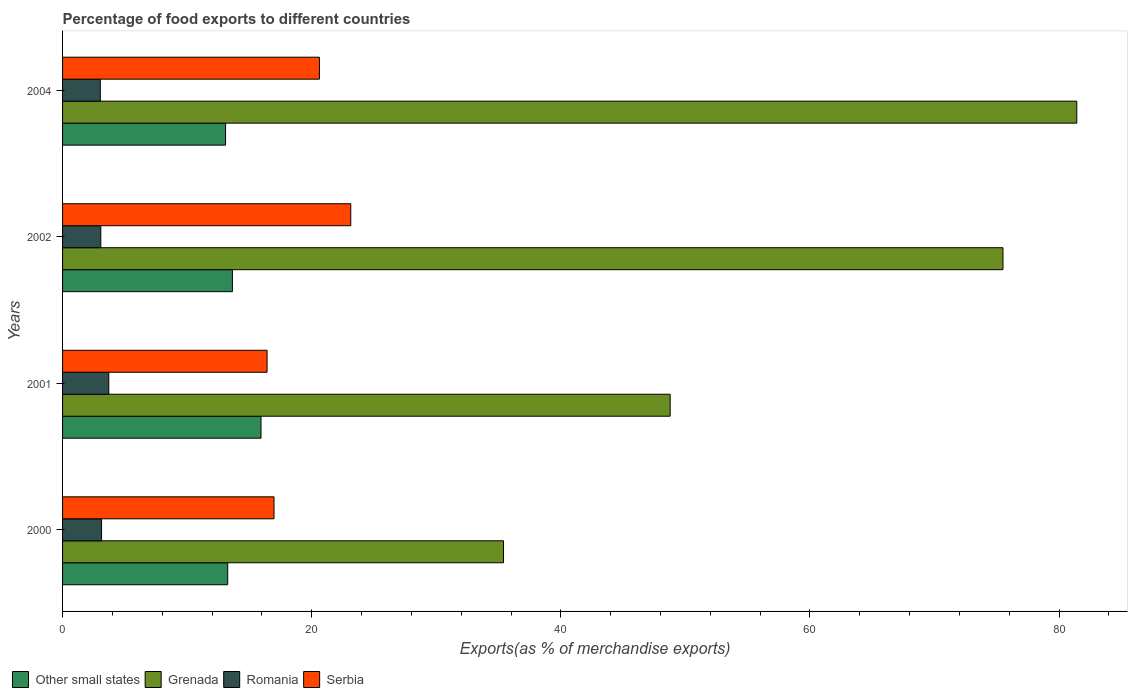How many groups of bars are there?
Give a very brief answer. 4. How many bars are there on the 4th tick from the bottom?
Your response must be concise. 4. What is the label of the 2nd group of bars from the top?
Offer a very short reply. 2002. In how many cases, is the number of bars for a given year not equal to the number of legend labels?
Offer a very short reply. 0. What is the percentage of exports to different countries in Romania in 2001?
Ensure brevity in your answer.  3.71. Across all years, what is the maximum percentage of exports to different countries in Grenada?
Offer a terse response. 81.42. Across all years, what is the minimum percentage of exports to different countries in Serbia?
Your answer should be very brief. 16.42. In which year was the percentage of exports to different countries in Other small states maximum?
Ensure brevity in your answer.  2001. What is the total percentage of exports to different countries in Romania in the graph?
Offer a very short reply. 12.94. What is the difference between the percentage of exports to different countries in Grenada in 2002 and that in 2004?
Offer a terse response. -5.92. What is the difference between the percentage of exports to different countries in Other small states in 2001 and the percentage of exports to different countries in Grenada in 2002?
Your response must be concise. -59.57. What is the average percentage of exports to different countries in Romania per year?
Provide a succinct answer. 3.23. In the year 2002, what is the difference between the percentage of exports to different countries in Other small states and percentage of exports to different countries in Serbia?
Provide a short and direct response. -9.5. What is the ratio of the percentage of exports to different countries in Romania in 2001 to that in 2004?
Offer a terse response. 1.23. Is the percentage of exports to different countries in Serbia in 2000 less than that in 2001?
Your response must be concise. No. Is the difference between the percentage of exports to different countries in Other small states in 2001 and 2002 greater than the difference between the percentage of exports to different countries in Serbia in 2001 and 2002?
Give a very brief answer. Yes. What is the difference between the highest and the second highest percentage of exports to different countries in Serbia?
Provide a short and direct response. 2.51. What is the difference between the highest and the lowest percentage of exports to different countries in Serbia?
Keep it short and to the point. 6.72. In how many years, is the percentage of exports to different countries in Grenada greater than the average percentage of exports to different countries in Grenada taken over all years?
Your answer should be compact. 2. Is it the case that in every year, the sum of the percentage of exports to different countries in Serbia and percentage of exports to different countries in Grenada is greater than the sum of percentage of exports to different countries in Other small states and percentage of exports to different countries in Romania?
Give a very brief answer. Yes. What does the 3rd bar from the top in 2000 represents?
Offer a very short reply. Grenada. What does the 3rd bar from the bottom in 2000 represents?
Provide a short and direct response. Romania. How many bars are there?
Ensure brevity in your answer.  16. Are all the bars in the graph horizontal?
Give a very brief answer. Yes. What is the difference between two consecutive major ticks on the X-axis?
Offer a terse response. 20. Are the values on the major ticks of X-axis written in scientific E-notation?
Keep it short and to the point. No. Where does the legend appear in the graph?
Ensure brevity in your answer.  Bottom left. How many legend labels are there?
Offer a terse response. 4. What is the title of the graph?
Keep it short and to the point. Percentage of food exports to different countries. What is the label or title of the X-axis?
Give a very brief answer. Exports(as % of merchandise exports). What is the Exports(as % of merchandise exports) in Other small states in 2000?
Keep it short and to the point. 13.26. What is the Exports(as % of merchandise exports) of Grenada in 2000?
Your answer should be very brief. 35.4. What is the Exports(as % of merchandise exports) in Romania in 2000?
Keep it short and to the point. 3.13. What is the Exports(as % of merchandise exports) in Serbia in 2000?
Offer a very short reply. 16.97. What is the Exports(as % of merchandise exports) in Other small states in 2001?
Your response must be concise. 15.93. What is the Exports(as % of merchandise exports) of Grenada in 2001?
Keep it short and to the point. 48.78. What is the Exports(as % of merchandise exports) in Romania in 2001?
Ensure brevity in your answer.  3.71. What is the Exports(as % of merchandise exports) of Serbia in 2001?
Provide a short and direct response. 16.42. What is the Exports(as % of merchandise exports) in Other small states in 2002?
Ensure brevity in your answer.  13.63. What is the Exports(as % of merchandise exports) of Grenada in 2002?
Make the answer very short. 75.49. What is the Exports(as % of merchandise exports) of Romania in 2002?
Provide a short and direct response. 3.07. What is the Exports(as % of merchandise exports) in Serbia in 2002?
Give a very brief answer. 23.14. What is the Exports(as % of merchandise exports) in Other small states in 2004?
Make the answer very short. 13.08. What is the Exports(as % of merchandise exports) of Grenada in 2004?
Make the answer very short. 81.42. What is the Exports(as % of merchandise exports) of Romania in 2004?
Your answer should be compact. 3.03. What is the Exports(as % of merchandise exports) in Serbia in 2004?
Ensure brevity in your answer.  20.62. Across all years, what is the maximum Exports(as % of merchandise exports) of Other small states?
Provide a short and direct response. 15.93. Across all years, what is the maximum Exports(as % of merchandise exports) in Grenada?
Make the answer very short. 81.42. Across all years, what is the maximum Exports(as % of merchandise exports) in Romania?
Make the answer very short. 3.71. Across all years, what is the maximum Exports(as % of merchandise exports) in Serbia?
Offer a terse response. 23.14. Across all years, what is the minimum Exports(as % of merchandise exports) in Other small states?
Provide a succinct answer. 13.08. Across all years, what is the minimum Exports(as % of merchandise exports) in Grenada?
Your response must be concise. 35.4. Across all years, what is the minimum Exports(as % of merchandise exports) in Romania?
Provide a succinct answer. 3.03. Across all years, what is the minimum Exports(as % of merchandise exports) in Serbia?
Offer a terse response. 16.42. What is the total Exports(as % of merchandise exports) in Other small states in the graph?
Your response must be concise. 55.91. What is the total Exports(as % of merchandise exports) in Grenada in the graph?
Your answer should be compact. 241.09. What is the total Exports(as % of merchandise exports) in Romania in the graph?
Make the answer very short. 12.94. What is the total Exports(as % of merchandise exports) in Serbia in the graph?
Your response must be concise. 77.15. What is the difference between the Exports(as % of merchandise exports) in Other small states in 2000 and that in 2001?
Keep it short and to the point. -2.67. What is the difference between the Exports(as % of merchandise exports) of Grenada in 2000 and that in 2001?
Your response must be concise. -13.38. What is the difference between the Exports(as % of merchandise exports) in Romania in 2000 and that in 2001?
Your response must be concise. -0.58. What is the difference between the Exports(as % of merchandise exports) in Serbia in 2000 and that in 2001?
Provide a succinct answer. 0.56. What is the difference between the Exports(as % of merchandise exports) in Other small states in 2000 and that in 2002?
Give a very brief answer. -0.38. What is the difference between the Exports(as % of merchandise exports) of Grenada in 2000 and that in 2002?
Your answer should be compact. -40.1. What is the difference between the Exports(as % of merchandise exports) in Romania in 2000 and that in 2002?
Offer a very short reply. 0.06. What is the difference between the Exports(as % of merchandise exports) of Serbia in 2000 and that in 2002?
Your answer should be very brief. -6.16. What is the difference between the Exports(as % of merchandise exports) of Other small states in 2000 and that in 2004?
Offer a terse response. 0.17. What is the difference between the Exports(as % of merchandise exports) of Grenada in 2000 and that in 2004?
Offer a terse response. -46.02. What is the difference between the Exports(as % of merchandise exports) in Romania in 2000 and that in 2004?
Your answer should be very brief. 0.1. What is the difference between the Exports(as % of merchandise exports) in Serbia in 2000 and that in 2004?
Make the answer very short. -3.65. What is the difference between the Exports(as % of merchandise exports) in Other small states in 2001 and that in 2002?
Keep it short and to the point. 2.3. What is the difference between the Exports(as % of merchandise exports) in Grenada in 2001 and that in 2002?
Your response must be concise. -26.72. What is the difference between the Exports(as % of merchandise exports) of Romania in 2001 and that in 2002?
Your response must be concise. 0.64. What is the difference between the Exports(as % of merchandise exports) of Serbia in 2001 and that in 2002?
Your answer should be compact. -6.72. What is the difference between the Exports(as % of merchandise exports) in Other small states in 2001 and that in 2004?
Offer a terse response. 2.84. What is the difference between the Exports(as % of merchandise exports) of Grenada in 2001 and that in 2004?
Your response must be concise. -32.64. What is the difference between the Exports(as % of merchandise exports) in Romania in 2001 and that in 2004?
Make the answer very short. 0.68. What is the difference between the Exports(as % of merchandise exports) in Serbia in 2001 and that in 2004?
Provide a short and direct response. -4.2. What is the difference between the Exports(as % of merchandise exports) in Other small states in 2002 and that in 2004?
Offer a terse response. 0.55. What is the difference between the Exports(as % of merchandise exports) in Grenada in 2002 and that in 2004?
Ensure brevity in your answer.  -5.92. What is the difference between the Exports(as % of merchandise exports) of Romania in 2002 and that in 2004?
Your response must be concise. 0.04. What is the difference between the Exports(as % of merchandise exports) in Serbia in 2002 and that in 2004?
Provide a short and direct response. 2.52. What is the difference between the Exports(as % of merchandise exports) of Other small states in 2000 and the Exports(as % of merchandise exports) of Grenada in 2001?
Your answer should be compact. -35.52. What is the difference between the Exports(as % of merchandise exports) in Other small states in 2000 and the Exports(as % of merchandise exports) in Romania in 2001?
Ensure brevity in your answer.  9.55. What is the difference between the Exports(as % of merchandise exports) of Other small states in 2000 and the Exports(as % of merchandise exports) of Serbia in 2001?
Offer a terse response. -3.16. What is the difference between the Exports(as % of merchandise exports) in Grenada in 2000 and the Exports(as % of merchandise exports) in Romania in 2001?
Your answer should be very brief. 31.69. What is the difference between the Exports(as % of merchandise exports) in Grenada in 2000 and the Exports(as % of merchandise exports) in Serbia in 2001?
Provide a short and direct response. 18.98. What is the difference between the Exports(as % of merchandise exports) in Romania in 2000 and the Exports(as % of merchandise exports) in Serbia in 2001?
Give a very brief answer. -13.29. What is the difference between the Exports(as % of merchandise exports) of Other small states in 2000 and the Exports(as % of merchandise exports) of Grenada in 2002?
Your answer should be very brief. -62.24. What is the difference between the Exports(as % of merchandise exports) in Other small states in 2000 and the Exports(as % of merchandise exports) in Romania in 2002?
Give a very brief answer. 10.19. What is the difference between the Exports(as % of merchandise exports) in Other small states in 2000 and the Exports(as % of merchandise exports) in Serbia in 2002?
Ensure brevity in your answer.  -9.88. What is the difference between the Exports(as % of merchandise exports) in Grenada in 2000 and the Exports(as % of merchandise exports) in Romania in 2002?
Offer a very short reply. 32.33. What is the difference between the Exports(as % of merchandise exports) of Grenada in 2000 and the Exports(as % of merchandise exports) of Serbia in 2002?
Your response must be concise. 12.26. What is the difference between the Exports(as % of merchandise exports) of Romania in 2000 and the Exports(as % of merchandise exports) of Serbia in 2002?
Provide a short and direct response. -20.01. What is the difference between the Exports(as % of merchandise exports) in Other small states in 2000 and the Exports(as % of merchandise exports) in Grenada in 2004?
Provide a short and direct response. -68.16. What is the difference between the Exports(as % of merchandise exports) in Other small states in 2000 and the Exports(as % of merchandise exports) in Romania in 2004?
Provide a short and direct response. 10.23. What is the difference between the Exports(as % of merchandise exports) of Other small states in 2000 and the Exports(as % of merchandise exports) of Serbia in 2004?
Offer a very short reply. -7.36. What is the difference between the Exports(as % of merchandise exports) of Grenada in 2000 and the Exports(as % of merchandise exports) of Romania in 2004?
Provide a succinct answer. 32.37. What is the difference between the Exports(as % of merchandise exports) of Grenada in 2000 and the Exports(as % of merchandise exports) of Serbia in 2004?
Keep it short and to the point. 14.78. What is the difference between the Exports(as % of merchandise exports) in Romania in 2000 and the Exports(as % of merchandise exports) in Serbia in 2004?
Offer a terse response. -17.49. What is the difference between the Exports(as % of merchandise exports) of Other small states in 2001 and the Exports(as % of merchandise exports) of Grenada in 2002?
Give a very brief answer. -59.57. What is the difference between the Exports(as % of merchandise exports) of Other small states in 2001 and the Exports(as % of merchandise exports) of Romania in 2002?
Offer a very short reply. 12.86. What is the difference between the Exports(as % of merchandise exports) in Other small states in 2001 and the Exports(as % of merchandise exports) in Serbia in 2002?
Your response must be concise. -7.21. What is the difference between the Exports(as % of merchandise exports) of Grenada in 2001 and the Exports(as % of merchandise exports) of Romania in 2002?
Ensure brevity in your answer.  45.71. What is the difference between the Exports(as % of merchandise exports) of Grenada in 2001 and the Exports(as % of merchandise exports) of Serbia in 2002?
Give a very brief answer. 25.64. What is the difference between the Exports(as % of merchandise exports) in Romania in 2001 and the Exports(as % of merchandise exports) in Serbia in 2002?
Offer a very short reply. -19.42. What is the difference between the Exports(as % of merchandise exports) in Other small states in 2001 and the Exports(as % of merchandise exports) in Grenada in 2004?
Make the answer very short. -65.49. What is the difference between the Exports(as % of merchandise exports) in Other small states in 2001 and the Exports(as % of merchandise exports) in Romania in 2004?
Ensure brevity in your answer.  12.9. What is the difference between the Exports(as % of merchandise exports) in Other small states in 2001 and the Exports(as % of merchandise exports) in Serbia in 2004?
Provide a short and direct response. -4.69. What is the difference between the Exports(as % of merchandise exports) in Grenada in 2001 and the Exports(as % of merchandise exports) in Romania in 2004?
Give a very brief answer. 45.75. What is the difference between the Exports(as % of merchandise exports) in Grenada in 2001 and the Exports(as % of merchandise exports) in Serbia in 2004?
Give a very brief answer. 28.16. What is the difference between the Exports(as % of merchandise exports) of Romania in 2001 and the Exports(as % of merchandise exports) of Serbia in 2004?
Make the answer very short. -16.91. What is the difference between the Exports(as % of merchandise exports) of Other small states in 2002 and the Exports(as % of merchandise exports) of Grenada in 2004?
Your answer should be compact. -67.79. What is the difference between the Exports(as % of merchandise exports) of Other small states in 2002 and the Exports(as % of merchandise exports) of Romania in 2004?
Provide a succinct answer. 10.61. What is the difference between the Exports(as % of merchandise exports) in Other small states in 2002 and the Exports(as % of merchandise exports) in Serbia in 2004?
Ensure brevity in your answer.  -6.99. What is the difference between the Exports(as % of merchandise exports) of Grenada in 2002 and the Exports(as % of merchandise exports) of Romania in 2004?
Offer a terse response. 72.47. What is the difference between the Exports(as % of merchandise exports) of Grenada in 2002 and the Exports(as % of merchandise exports) of Serbia in 2004?
Ensure brevity in your answer.  54.87. What is the difference between the Exports(as % of merchandise exports) in Romania in 2002 and the Exports(as % of merchandise exports) in Serbia in 2004?
Your answer should be very brief. -17.55. What is the average Exports(as % of merchandise exports) in Other small states per year?
Ensure brevity in your answer.  13.98. What is the average Exports(as % of merchandise exports) of Grenada per year?
Your answer should be compact. 60.27. What is the average Exports(as % of merchandise exports) of Romania per year?
Provide a succinct answer. 3.23. What is the average Exports(as % of merchandise exports) of Serbia per year?
Offer a terse response. 19.29. In the year 2000, what is the difference between the Exports(as % of merchandise exports) of Other small states and Exports(as % of merchandise exports) of Grenada?
Your answer should be very brief. -22.14. In the year 2000, what is the difference between the Exports(as % of merchandise exports) in Other small states and Exports(as % of merchandise exports) in Romania?
Provide a succinct answer. 10.13. In the year 2000, what is the difference between the Exports(as % of merchandise exports) in Other small states and Exports(as % of merchandise exports) in Serbia?
Offer a very short reply. -3.72. In the year 2000, what is the difference between the Exports(as % of merchandise exports) of Grenada and Exports(as % of merchandise exports) of Romania?
Give a very brief answer. 32.27. In the year 2000, what is the difference between the Exports(as % of merchandise exports) of Grenada and Exports(as % of merchandise exports) of Serbia?
Provide a short and direct response. 18.42. In the year 2000, what is the difference between the Exports(as % of merchandise exports) of Romania and Exports(as % of merchandise exports) of Serbia?
Your response must be concise. -13.84. In the year 2001, what is the difference between the Exports(as % of merchandise exports) in Other small states and Exports(as % of merchandise exports) in Grenada?
Your answer should be compact. -32.85. In the year 2001, what is the difference between the Exports(as % of merchandise exports) in Other small states and Exports(as % of merchandise exports) in Romania?
Offer a very short reply. 12.22. In the year 2001, what is the difference between the Exports(as % of merchandise exports) of Other small states and Exports(as % of merchandise exports) of Serbia?
Offer a terse response. -0.49. In the year 2001, what is the difference between the Exports(as % of merchandise exports) of Grenada and Exports(as % of merchandise exports) of Romania?
Your answer should be compact. 45.07. In the year 2001, what is the difference between the Exports(as % of merchandise exports) of Grenada and Exports(as % of merchandise exports) of Serbia?
Your answer should be very brief. 32.36. In the year 2001, what is the difference between the Exports(as % of merchandise exports) of Romania and Exports(as % of merchandise exports) of Serbia?
Provide a short and direct response. -12.71. In the year 2002, what is the difference between the Exports(as % of merchandise exports) in Other small states and Exports(as % of merchandise exports) in Grenada?
Your answer should be compact. -61.86. In the year 2002, what is the difference between the Exports(as % of merchandise exports) of Other small states and Exports(as % of merchandise exports) of Romania?
Your answer should be very brief. 10.57. In the year 2002, what is the difference between the Exports(as % of merchandise exports) in Other small states and Exports(as % of merchandise exports) in Serbia?
Your answer should be compact. -9.5. In the year 2002, what is the difference between the Exports(as % of merchandise exports) in Grenada and Exports(as % of merchandise exports) in Romania?
Make the answer very short. 72.43. In the year 2002, what is the difference between the Exports(as % of merchandise exports) of Grenada and Exports(as % of merchandise exports) of Serbia?
Keep it short and to the point. 52.36. In the year 2002, what is the difference between the Exports(as % of merchandise exports) of Romania and Exports(as % of merchandise exports) of Serbia?
Offer a terse response. -20.07. In the year 2004, what is the difference between the Exports(as % of merchandise exports) in Other small states and Exports(as % of merchandise exports) in Grenada?
Keep it short and to the point. -68.33. In the year 2004, what is the difference between the Exports(as % of merchandise exports) in Other small states and Exports(as % of merchandise exports) in Romania?
Your answer should be compact. 10.06. In the year 2004, what is the difference between the Exports(as % of merchandise exports) in Other small states and Exports(as % of merchandise exports) in Serbia?
Make the answer very short. -7.54. In the year 2004, what is the difference between the Exports(as % of merchandise exports) in Grenada and Exports(as % of merchandise exports) in Romania?
Keep it short and to the point. 78.39. In the year 2004, what is the difference between the Exports(as % of merchandise exports) of Grenada and Exports(as % of merchandise exports) of Serbia?
Provide a succinct answer. 60.8. In the year 2004, what is the difference between the Exports(as % of merchandise exports) in Romania and Exports(as % of merchandise exports) in Serbia?
Keep it short and to the point. -17.59. What is the ratio of the Exports(as % of merchandise exports) of Other small states in 2000 to that in 2001?
Your answer should be compact. 0.83. What is the ratio of the Exports(as % of merchandise exports) in Grenada in 2000 to that in 2001?
Offer a very short reply. 0.73. What is the ratio of the Exports(as % of merchandise exports) in Romania in 2000 to that in 2001?
Your response must be concise. 0.84. What is the ratio of the Exports(as % of merchandise exports) of Serbia in 2000 to that in 2001?
Provide a short and direct response. 1.03. What is the ratio of the Exports(as % of merchandise exports) in Other small states in 2000 to that in 2002?
Your answer should be compact. 0.97. What is the ratio of the Exports(as % of merchandise exports) of Grenada in 2000 to that in 2002?
Make the answer very short. 0.47. What is the ratio of the Exports(as % of merchandise exports) of Romania in 2000 to that in 2002?
Offer a terse response. 1.02. What is the ratio of the Exports(as % of merchandise exports) in Serbia in 2000 to that in 2002?
Your response must be concise. 0.73. What is the ratio of the Exports(as % of merchandise exports) in Other small states in 2000 to that in 2004?
Your answer should be very brief. 1.01. What is the ratio of the Exports(as % of merchandise exports) of Grenada in 2000 to that in 2004?
Offer a terse response. 0.43. What is the ratio of the Exports(as % of merchandise exports) in Romania in 2000 to that in 2004?
Your answer should be very brief. 1.03. What is the ratio of the Exports(as % of merchandise exports) of Serbia in 2000 to that in 2004?
Make the answer very short. 0.82. What is the ratio of the Exports(as % of merchandise exports) in Other small states in 2001 to that in 2002?
Give a very brief answer. 1.17. What is the ratio of the Exports(as % of merchandise exports) of Grenada in 2001 to that in 2002?
Provide a short and direct response. 0.65. What is the ratio of the Exports(as % of merchandise exports) of Romania in 2001 to that in 2002?
Ensure brevity in your answer.  1.21. What is the ratio of the Exports(as % of merchandise exports) in Serbia in 2001 to that in 2002?
Offer a terse response. 0.71. What is the ratio of the Exports(as % of merchandise exports) in Other small states in 2001 to that in 2004?
Keep it short and to the point. 1.22. What is the ratio of the Exports(as % of merchandise exports) in Grenada in 2001 to that in 2004?
Your response must be concise. 0.6. What is the ratio of the Exports(as % of merchandise exports) of Romania in 2001 to that in 2004?
Provide a succinct answer. 1.23. What is the ratio of the Exports(as % of merchandise exports) in Serbia in 2001 to that in 2004?
Keep it short and to the point. 0.8. What is the ratio of the Exports(as % of merchandise exports) of Other small states in 2002 to that in 2004?
Keep it short and to the point. 1.04. What is the ratio of the Exports(as % of merchandise exports) of Grenada in 2002 to that in 2004?
Provide a short and direct response. 0.93. What is the ratio of the Exports(as % of merchandise exports) in Romania in 2002 to that in 2004?
Ensure brevity in your answer.  1.01. What is the ratio of the Exports(as % of merchandise exports) in Serbia in 2002 to that in 2004?
Give a very brief answer. 1.12. What is the difference between the highest and the second highest Exports(as % of merchandise exports) in Other small states?
Your answer should be compact. 2.3. What is the difference between the highest and the second highest Exports(as % of merchandise exports) in Grenada?
Your answer should be compact. 5.92. What is the difference between the highest and the second highest Exports(as % of merchandise exports) in Romania?
Offer a terse response. 0.58. What is the difference between the highest and the second highest Exports(as % of merchandise exports) in Serbia?
Give a very brief answer. 2.52. What is the difference between the highest and the lowest Exports(as % of merchandise exports) in Other small states?
Your answer should be very brief. 2.84. What is the difference between the highest and the lowest Exports(as % of merchandise exports) of Grenada?
Ensure brevity in your answer.  46.02. What is the difference between the highest and the lowest Exports(as % of merchandise exports) in Romania?
Make the answer very short. 0.68. What is the difference between the highest and the lowest Exports(as % of merchandise exports) of Serbia?
Your answer should be very brief. 6.72. 